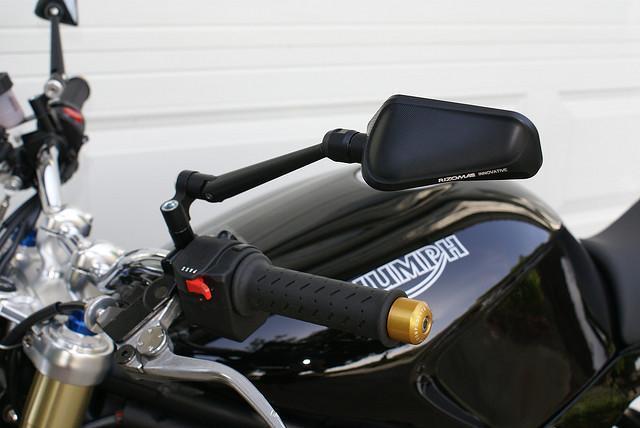How many cars are parked in this picture?
Give a very brief answer. 0. 